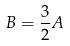<formula> <loc_0><loc_0><loc_500><loc_500>B = \frac { 3 } { 2 } A</formula> 